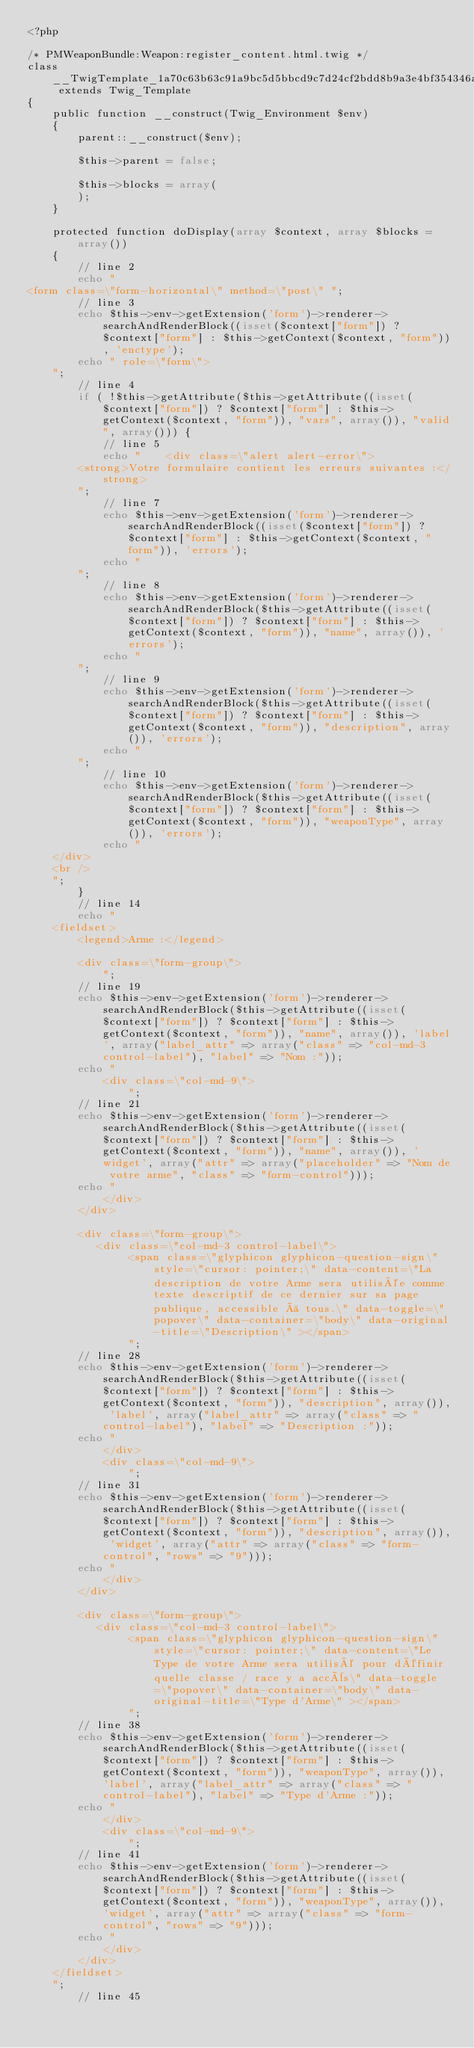Convert code to text. <code><loc_0><loc_0><loc_500><loc_500><_PHP_><?php

/* PMWeaponBundle:Weapon:register_content.html.twig */
class __TwigTemplate_1a70c63b63c91a9bc5d5bbcd9c7d24cf2bdd8b9a3e4bf354346ae3b058498614 extends Twig_Template
{
    public function __construct(Twig_Environment $env)
    {
        parent::__construct($env);

        $this->parent = false;

        $this->blocks = array(
        );
    }

    protected function doDisplay(array $context, array $blocks = array())
    {
        // line 2
        echo "
<form class=\"form-horizontal\" method=\"post\" ";
        // line 3
        echo $this->env->getExtension('form')->renderer->searchAndRenderBlock((isset($context["form"]) ? $context["form"] : $this->getContext($context, "form")), 'enctype');
        echo " role=\"form\">
    ";
        // line 4
        if ( !$this->getAttribute($this->getAttribute((isset($context["form"]) ? $context["form"] : $this->getContext($context, "form")), "vars", array()), "valid", array())) {
            // line 5
            echo "    <div class=\"alert alert-error\">
        <strong>Votre formulaire contient les erreurs suivantes :</strong>
        ";
            // line 7
            echo $this->env->getExtension('form')->renderer->searchAndRenderBlock((isset($context["form"]) ? $context["form"] : $this->getContext($context, "form")), 'errors');
            echo "
        ";
            // line 8
            echo $this->env->getExtension('form')->renderer->searchAndRenderBlock($this->getAttribute((isset($context["form"]) ? $context["form"] : $this->getContext($context, "form")), "name", array()), 'errors');
            echo "
        ";
            // line 9
            echo $this->env->getExtension('form')->renderer->searchAndRenderBlock($this->getAttribute((isset($context["form"]) ? $context["form"] : $this->getContext($context, "form")), "description", array()), 'errors');
            echo "
        ";
            // line 10
            echo $this->env->getExtension('form')->renderer->searchAndRenderBlock($this->getAttribute((isset($context["form"]) ? $context["form"] : $this->getContext($context, "form")), "weaponType", array()), 'errors');
            echo "
    </div>
    <br />
    ";
        }
        // line 14
        echo "
    <fieldset>
        <legend>Arme :</legend>

        <div class=\"form-group\">
            ";
        // line 19
        echo $this->env->getExtension('form')->renderer->searchAndRenderBlock($this->getAttribute((isset($context["form"]) ? $context["form"] : $this->getContext($context, "form")), "name", array()), 'label', array("label_attr" => array("class" => "col-md-3 control-label"), "label" => "Nom :"));
        echo "
            <div class=\"col-md-9\">
                ";
        // line 21
        echo $this->env->getExtension('form')->renderer->searchAndRenderBlock($this->getAttribute((isset($context["form"]) ? $context["form"] : $this->getContext($context, "form")), "name", array()), 'widget', array("attr" => array("placeholder" => "Nom de votre arme", "class" => "form-control")));
        echo "
            </div>
        </div>

        <div class=\"form-group\">
           <div class=\"col-md-3 control-label\">
                <span class=\"glyphicon glyphicon-question-sign\" style=\"cursor: pointer;\" data-content=\"La description de votre Arme sera utilisée comme texte descriptif de ce dernier sur sa page publique, accessible à tous.\" data-toggle=\"popover\" data-container=\"body\" data-original-title=\"Description\" ></span>
                ";
        // line 28
        echo $this->env->getExtension('form')->renderer->searchAndRenderBlock($this->getAttribute((isset($context["form"]) ? $context["form"] : $this->getContext($context, "form")), "description", array()), 'label', array("label_attr" => array("class" => "control-label"), "label" => "Description :"));
        echo "
            </div>
            <div class=\"col-md-9\">
                ";
        // line 31
        echo $this->env->getExtension('form')->renderer->searchAndRenderBlock($this->getAttribute((isset($context["form"]) ? $context["form"] : $this->getContext($context, "form")), "description", array()), 'widget', array("attr" => array("class" => "form-control", "rows" => "9")));
        echo "
            </div>
        </div>

        <div class=\"form-group\">
           <div class=\"col-md-3 control-label\">
                <span class=\"glyphicon glyphicon-question-sign\" style=\"cursor: pointer;\" data-content=\"Le Type de votre Arme sera utilisé pour définir quelle classe / race y a accès\" data-toggle=\"popover\" data-container=\"body\" data-original-title=\"Type d'Arme\" ></span>
                ";
        // line 38
        echo $this->env->getExtension('form')->renderer->searchAndRenderBlock($this->getAttribute((isset($context["form"]) ? $context["form"] : $this->getContext($context, "form")), "weaponType", array()), 'label', array("label_attr" => array("class" => "control-label"), "label" => "Type d'Arme :"));
        echo "
            </div>
            <div class=\"col-md-9\">
                ";
        // line 41
        echo $this->env->getExtension('form')->renderer->searchAndRenderBlock($this->getAttribute((isset($context["form"]) ? $context["form"] : $this->getContext($context, "form")), "weaponType", array()), 'widget', array("attr" => array("class" => "form-control", "rows" => "9")));
        echo "
            </div>
        </div>
    </fieldset>
    ";
        // line 45</code> 